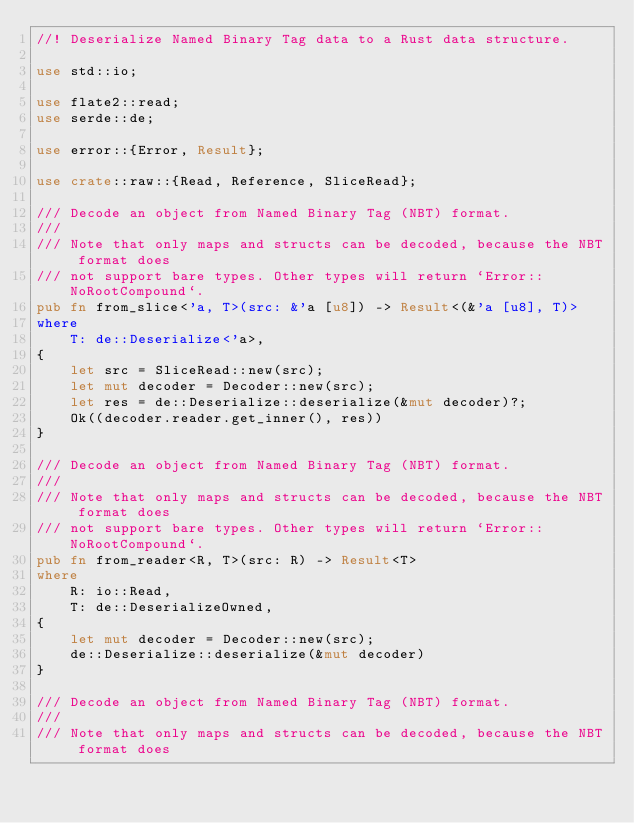Convert code to text. <code><loc_0><loc_0><loc_500><loc_500><_Rust_>//! Deserialize Named Binary Tag data to a Rust data structure.

use std::io;

use flate2::read;
use serde::de;

use error::{Error, Result};

use crate::raw::{Read, Reference, SliceRead};

/// Decode an object from Named Binary Tag (NBT) format.
///
/// Note that only maps and structs can be decoded, because the NBT format does
/// not support bare types. Other types will return `Error::NoRootCompound`.
pub fn from_slice<'a, T>(src: &'a [u8]) -> Result<(&'a [u8], T)>
where
    T: de::Deserialize<'a>,
{
    let src = SliceRead::new(src);
    let mut decoder = Decoder::new(src);
    let res = de::Deserialize::deserialize(&mut decoder)?;
    Ok((decoder.reader.get_inner(), res))
}

/// Decode an object from Named Binary Tag (NBT) format.
///
/// Note that only maps and structs can be decoded, because the NBT format does
/// not support bare types. Other types will return `Error::NoRootCompound`.
pub fn from_reader<R, T>(src: R) -> Result<T>
where
    R: io::Read,
    T: de::DeserializeOwned,
{
    let mut decoder = Decoder::new(src);
    de::Deserialize::deserialize(&mut decoder)
}

/// Decode an object from Named Binary Tag (NBT) format.
///
/// Note that only maps and structs can be decoded, because the NBT format does</code> 